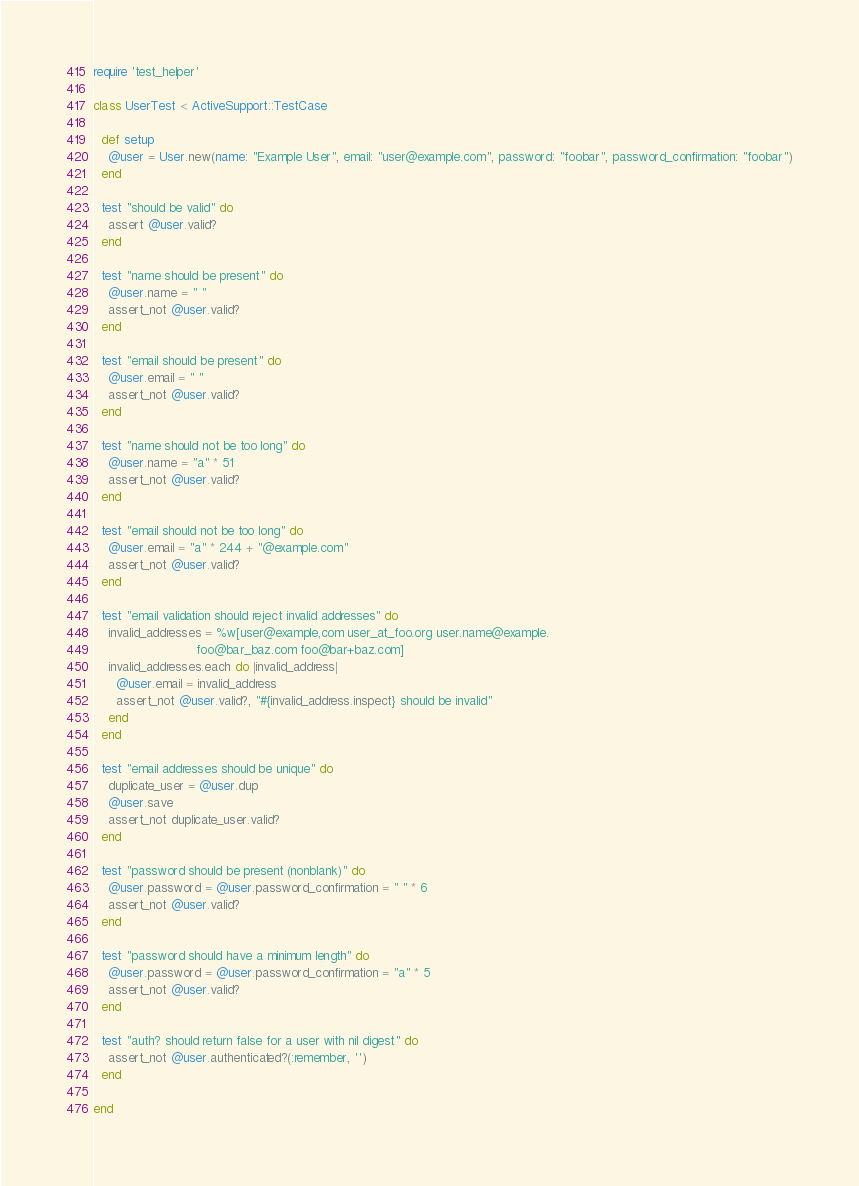<code> <loc_0><loc_0><loc_500><loc_500><_Ruby_>require 'test_helper'

class UserTest < ActiveSupport::TestCase
  
  def setup
    @user = User.new(name: "Example User", email: "user@example.com", password: "foobar", password_confirmation: "foobar")
  end
  
  test "should be valid" do 
    assert @user.valid?
  end
  
  test "name should be present" do
    @user.name = " "
    assert_not @user.valid?
  end
  
  test "email should be present" do
    @user.email = " "
    assert_not @user.valid?
  end
  
  test "name should not be too long" do
    @user.name = "a" * 51
    assert_not @user.valid?
  end

  test "email should not be too long" do
    @user.email = "a" * 244 + "@example.com"
    assert_not @user.valid?
  end
  
  test "email validation should reject invalid addresses" do
    invalid_addresses = %w[user@example,com user_at_foo.org user.name@example.
                           foo@bar_baz.com foo@bar+baz.com]
    invalid_addresses.each do |invalid_address|
      @user.email = invalid_address
      assert_not @user.valid?, "#{invalid_address.inspect} should be invalid"
    end
  end
  
  test "email addresses should be unique" do
    duplicate_user = @user.dup
    @user.save
    assert_not duplicate_user.valid?
  end

  test "password should be present (nonblank)" do
    @user.password = @user.password_confirmation = " " * 6
    assert_not @user.valid?
  end

  test "password should have a minimum length" do
    @user.password = @user.password_confirmation = "a" * 5
    assert_not @user.valid?
  end

  test "auth? should return false for a user with nil digest" do
    assert_not @user.authenticated?(:remember, '')
  end

end
</code> 